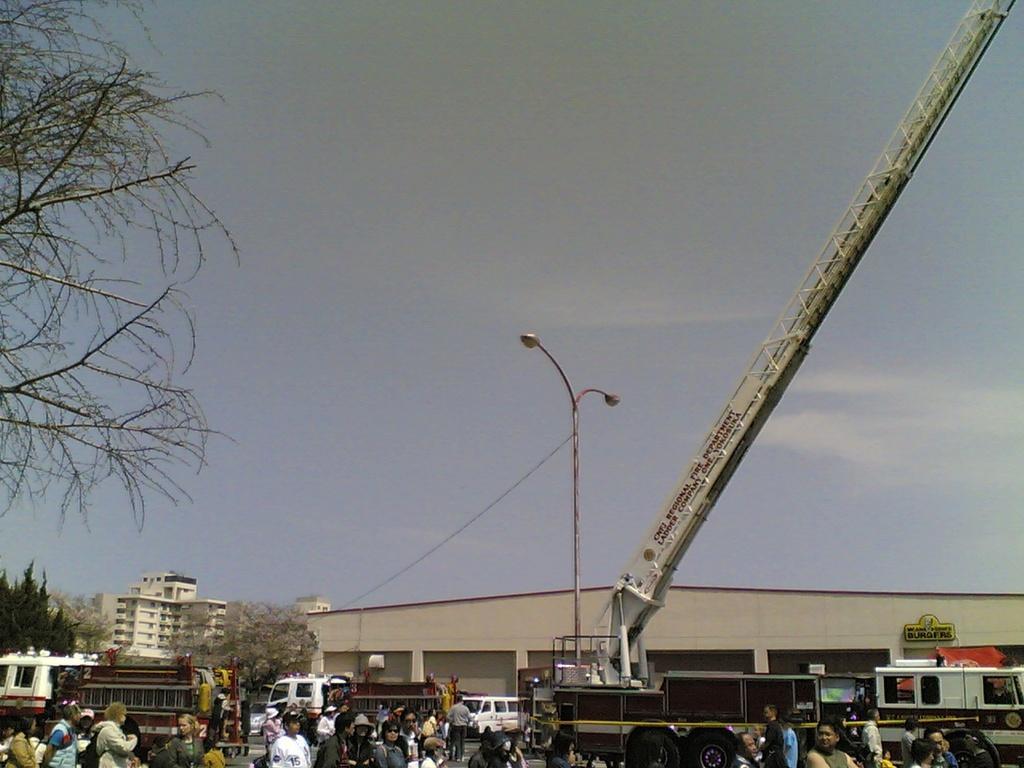Can you describe this image briefly? In this picture I can observe a mobile crane on the right side. In the middle of the picture there is a pole to which lights are fixed. On the bottom of the picture I can observe some vehicles and there are some people on the road. I can observe building on the left side. In the background there is sky. 